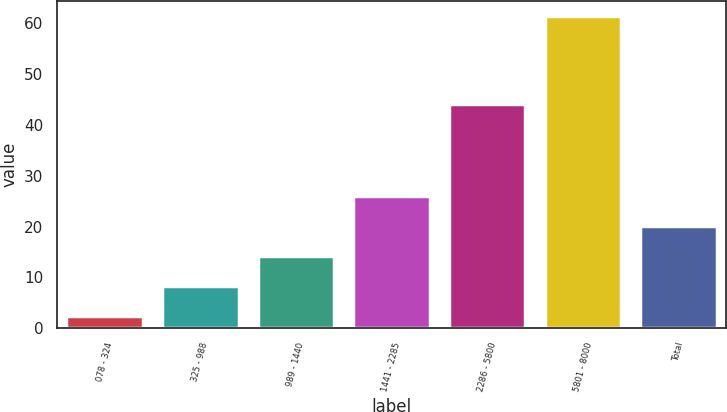<chart> <loc_0><loc_0><loc_500><loc_500><bar_chart><fcel>078 - 324<fcel>325 - 988<fcel>989 - 1440<fcel>1441 - 2285<fcel>2286 - 5800<fcel>5801 - 8000<fcel>Total<nl><fcel>2.4<fcel>8.29<fcel>14.18<fcel>25.96<fcel>44.09<fcel>61.28<fcel>20.07<nl></chart> 